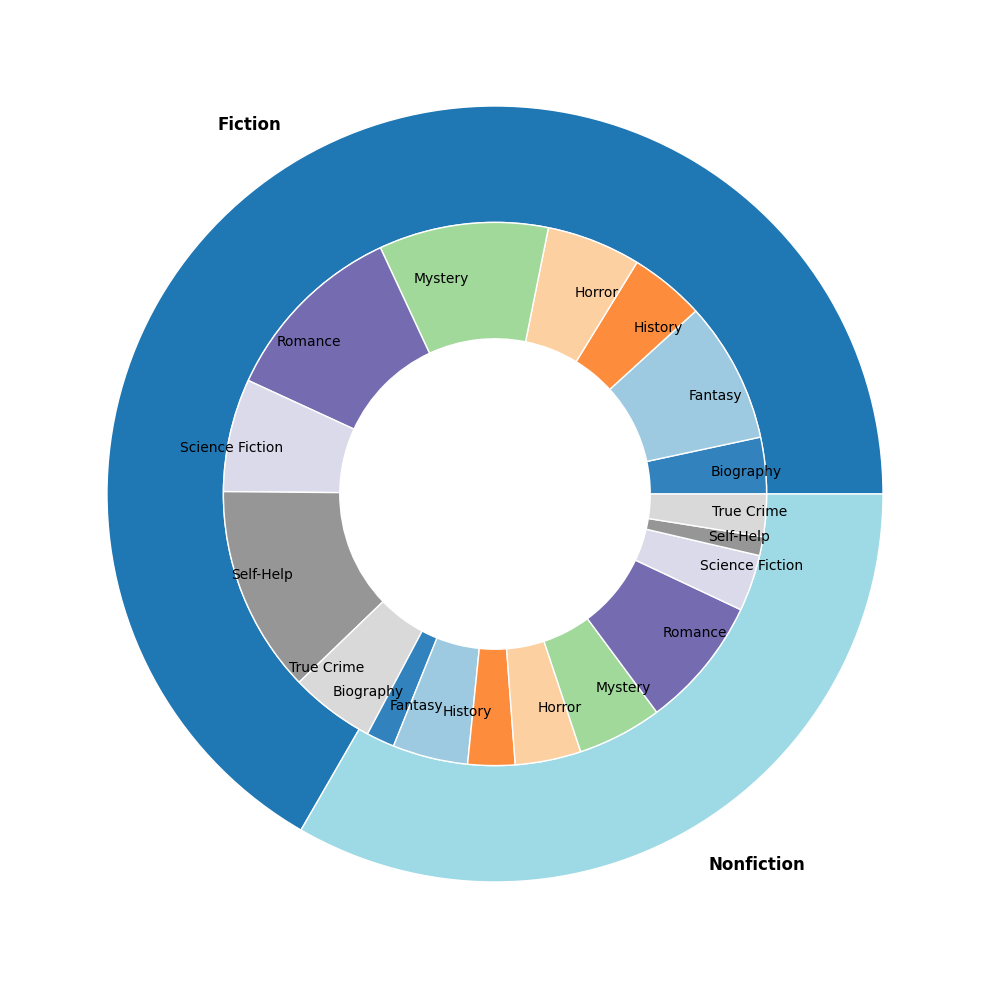What is the total count of Fiction literature and film subgenres combined? To find the total count, add up the counts of all subgenres within the Fiction genre for both literature and film. That is 150 (Fantasy Literature) + 80 (Fantasy Film) + 120 (Science Fiction Literature) + 60 (Science Fiction Film) + 200 (Romance Literature) + 140 (Romance Film) + 100 (Horror Literature) + 70 (Horror Film) + 180 (Mystery Literature) + 90 (Mystery Film).
Answer: 1190 Which Fiction subgenre has the highest count in Literature? Look at the outer ring of the nested pie chart representing Fiction literature subgenres and identify the wedge with the largest size. Romance appears largest. Romance Literature has 200.
Answer: Romance How does the count of Science Fiction films compare to Mystery films? Locate the subgenre wedges for Science Fiction and Mystery within the film medium in the inner ring. The count for Science Fiction Film is 60 and for Mystery Film is 90. Compare the two values: 60 < 90.
Answer: Mystery films have a higher count Are there more counts of Nonfiction literature or film for the subgenre Biography? Compare the sizes of the wedges representing Biography in the Nonfiction literature and film categories. Biography Literature has 60 and Biography Film has 30. 60 > 30.
Answer: Nonfiction literature In which medium (Literature or Film) does the Self-Help subgenre have a greater representation? Compare the Self-Help wedges in both literature and film mediums. The count for Self-Help Literature is 220 and for Self-Help Film is 20. 220 > 20.
Answer: Literature 